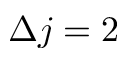<formula> <loc_0><loc_0><loc_500><loc_500>\Delta j = 2</formula> 